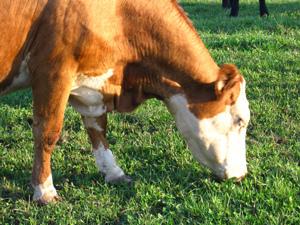What is on the cows' ears?
Give a very brief answer. Tag. Is the grass green?
Quick response, please. Yes. What kind of animal is this?
Give a very brief answer. Cow. What is the cow eating?
Keep it brief. Grass. 